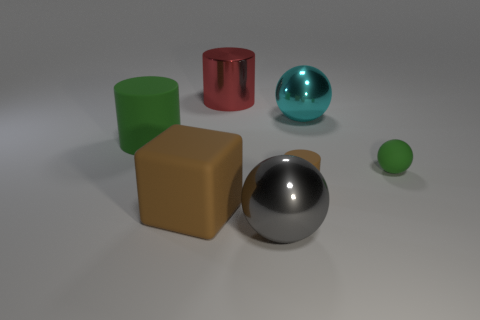Add 1 gray metallic spheres. How many objects exist? 8 Subtract all spheres. How many objects are left? 4 Add 3 green rubber spheres. How many green rubber spheres exist? 4 Subtract 0 purple cylinders. How many objects are left? 7 Subtract all big cyan things. Subtract all tiny matte objects. How many objects are left? 4 Add 4 red cylinders. How many red cylinders are left? 5 